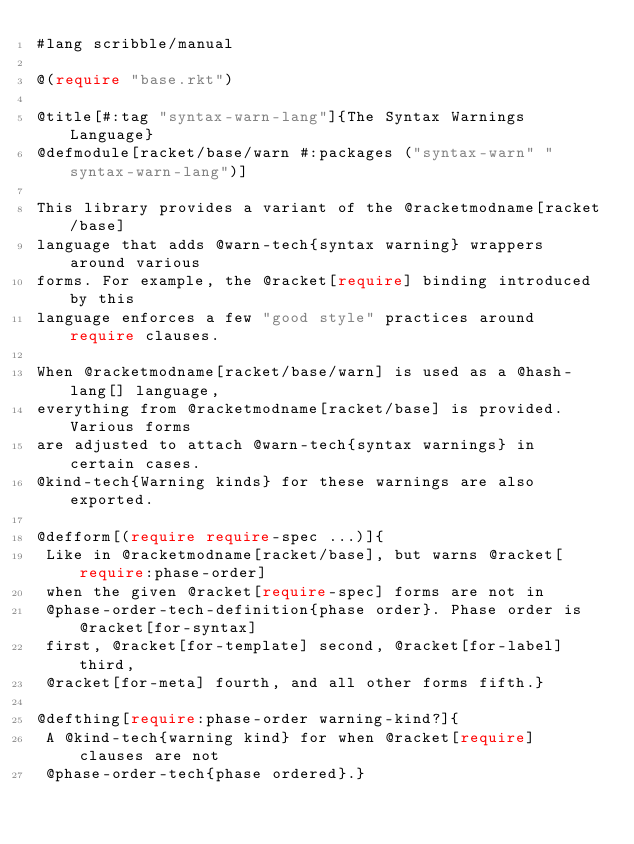<code> <loc_0><loc_0><loc_500><loc_500><_Racket_>#lang scribble/manual

@(require "base.rkt")

@title[#:tag "syntax-warn-lang"]{The Syntax Warnings Language}
@defmodule[racket/base/warn #:packages ("syntax-warn" "syntax-warn-lang")]

This library provides a variant of the @racketmodname[racket/base]
language that adds @warn-tech{syntax warning} wrappers around various
forms. For example, the @racket[require] binding introduced by this
language enforces a few "good style" practices around require clauses.

When @racketmodname[racket/base/warn] is used as a @hash-lang[] language,
everything from @racketmodname[racket/base] is provided. Various forms
are adjusted to attach @warn-tech{syntax warnings} in certain cases.
@kind-tech{Warning kinds} for these warnings are also exported.

@defform[(require require-spec ...)]{
 Like in @racketmodname[racket/base], but warns @racket[require:phase-order]
 when the given @racket[require-spec] forms are not in
 @phase-order-tech-definition{phase order}. Phase order is @racket[for-syntax]
 first, @racket[for-template] second, @racket[for-label] third,
 @racket[for-meta] fourth, and all other forms fifth.}

@defthing[require:phase-order warning-kind?]{
 A @kind-tech{warning kind} for when @racket[require] clauses are not
 @phase-order-tech{phase ordered}.}
</code> 